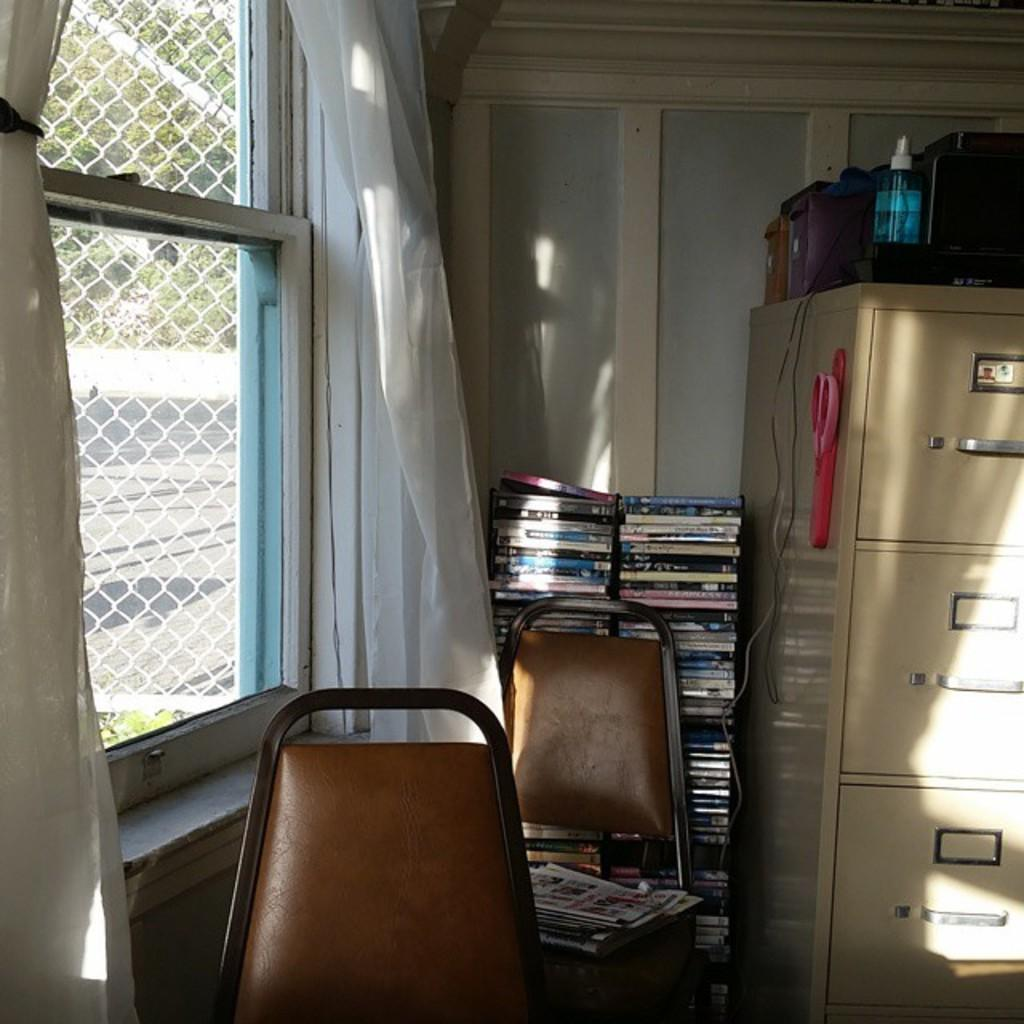What type of furniture can be seen in the image? There are chairs in the image. What reading materials are present in the image? There are newspapers and books in the image. What storage unit is visible in the image? There is a cupboard in the image. What type of tool is present in the image? There is a scissor in the image. What type of container is present in the image? There is a bottle in the image. What type of storage units are present in the image? There are boxes in the image. What architectural feature is visible in the image? There is a wall in the image. What window treatment is present in the image? There is a window with curtains in the image. What can be seen through the window in the image? The road and trees are visible through the window. What type of winter clothing is visible in the image? There is no winter clothing present in the image. What type of bomb can be seen in the image? There is no bomb present in the image. What type of relation is depicted between the people in the image? There are no people present in the image, so it is not possible to determine any relations between them. 